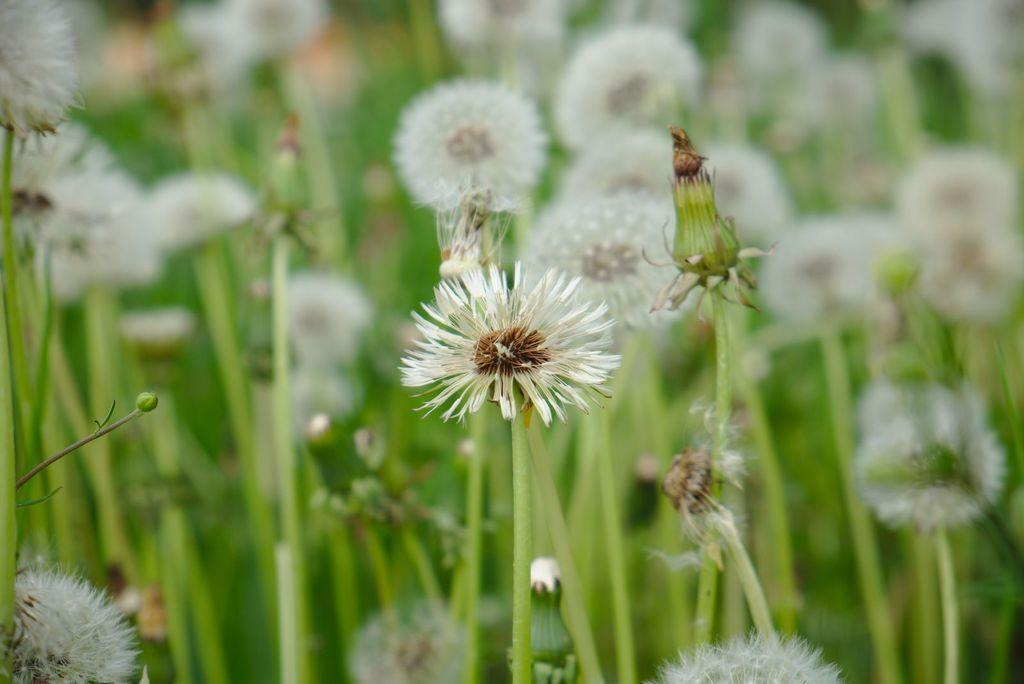What type of living organisms can be seen in the image? Plants can be seen in the image. How much fire is present in the image? There is no fire present in the image; it only contains plants. What is the reason for the plants being in the image? The fact provided does not give any information about the reason for the plants being in the image, so we cannot answer this question definitively. 